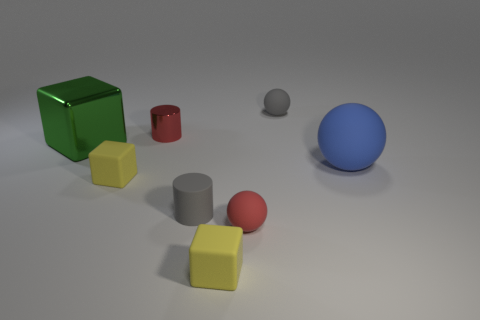There is a small rubber object that is the same shape as the small red metallic thing; what color is it? The small rubber object that shares its shape with the small red metallic cylinder is gray in color, exhibiting a matte texture that contrasts with the metallic sheen of the red object. 